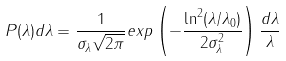<formula> <loc_0><loc_0><loc_500><loc_500>P ( \lambda ) d \lambda = \frac { 1 } { \sigma _ { \lambda } \sqrt { 2 \pi } } e x p \left ( - \frac { \ln ^ { 2 } ( \lambda / \lambda _ { 0 } ) } { 2 \sigma ^ { 2 } _ { \lambda } } \right ) \frac { d \lambda } { \lambda }</formula> 